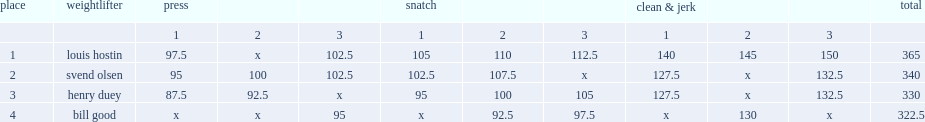What was louis hostin's result in press(kilos)? 102.5. 